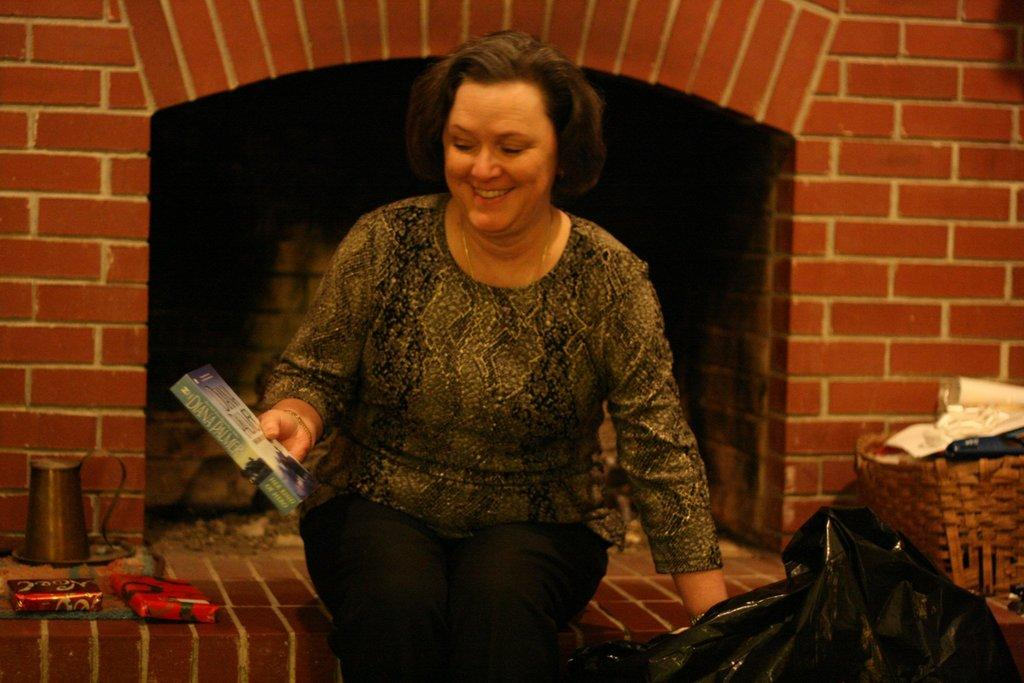Who is present in the image? There is a woman in the image. What is the woman doing in the image? The woman is sitting in the image. What is the woman holding in her hand? The woman is holding a box in her hand. What can be seen in the background of the image? There are objects, a basket, a cover, and a wall in the background of the image. Where might this image have been taken? The image may have been taken in a hall. Is there a cobweb visible in the image? There is no mention of a cobweb in the provided facts, so it cannot be determined if one is present in the image. What type of judgment is the judge making in the image? There is no judge present in the image, so it is not possible to answer this question. 